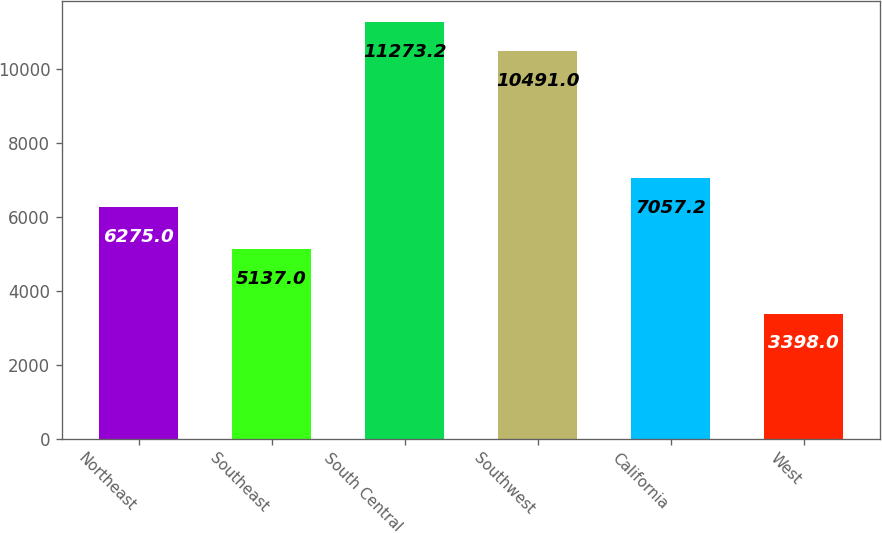Convert chart to OTSL. <chart><loc_0><loc_0><loc_500><loc_500><bar_chart><fcel>Northeast<fcel>Southeast<fcel>South Central<fcel>Southwest<fcel>California<fcel>West<nl><fcel>6275<fcel>5137<fcel>11273.2<fcel>10491<fcel>7057.2<fcel>3398<nl></chart> 